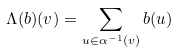Convert formula to latex. <formula><loc_0><loc_0><loc_500><loc_500>\Lambda ( b ) ( v ) = \sum _ { u \in \alpha ^ { - 1 } ( v ) } b ( u )</formula> 